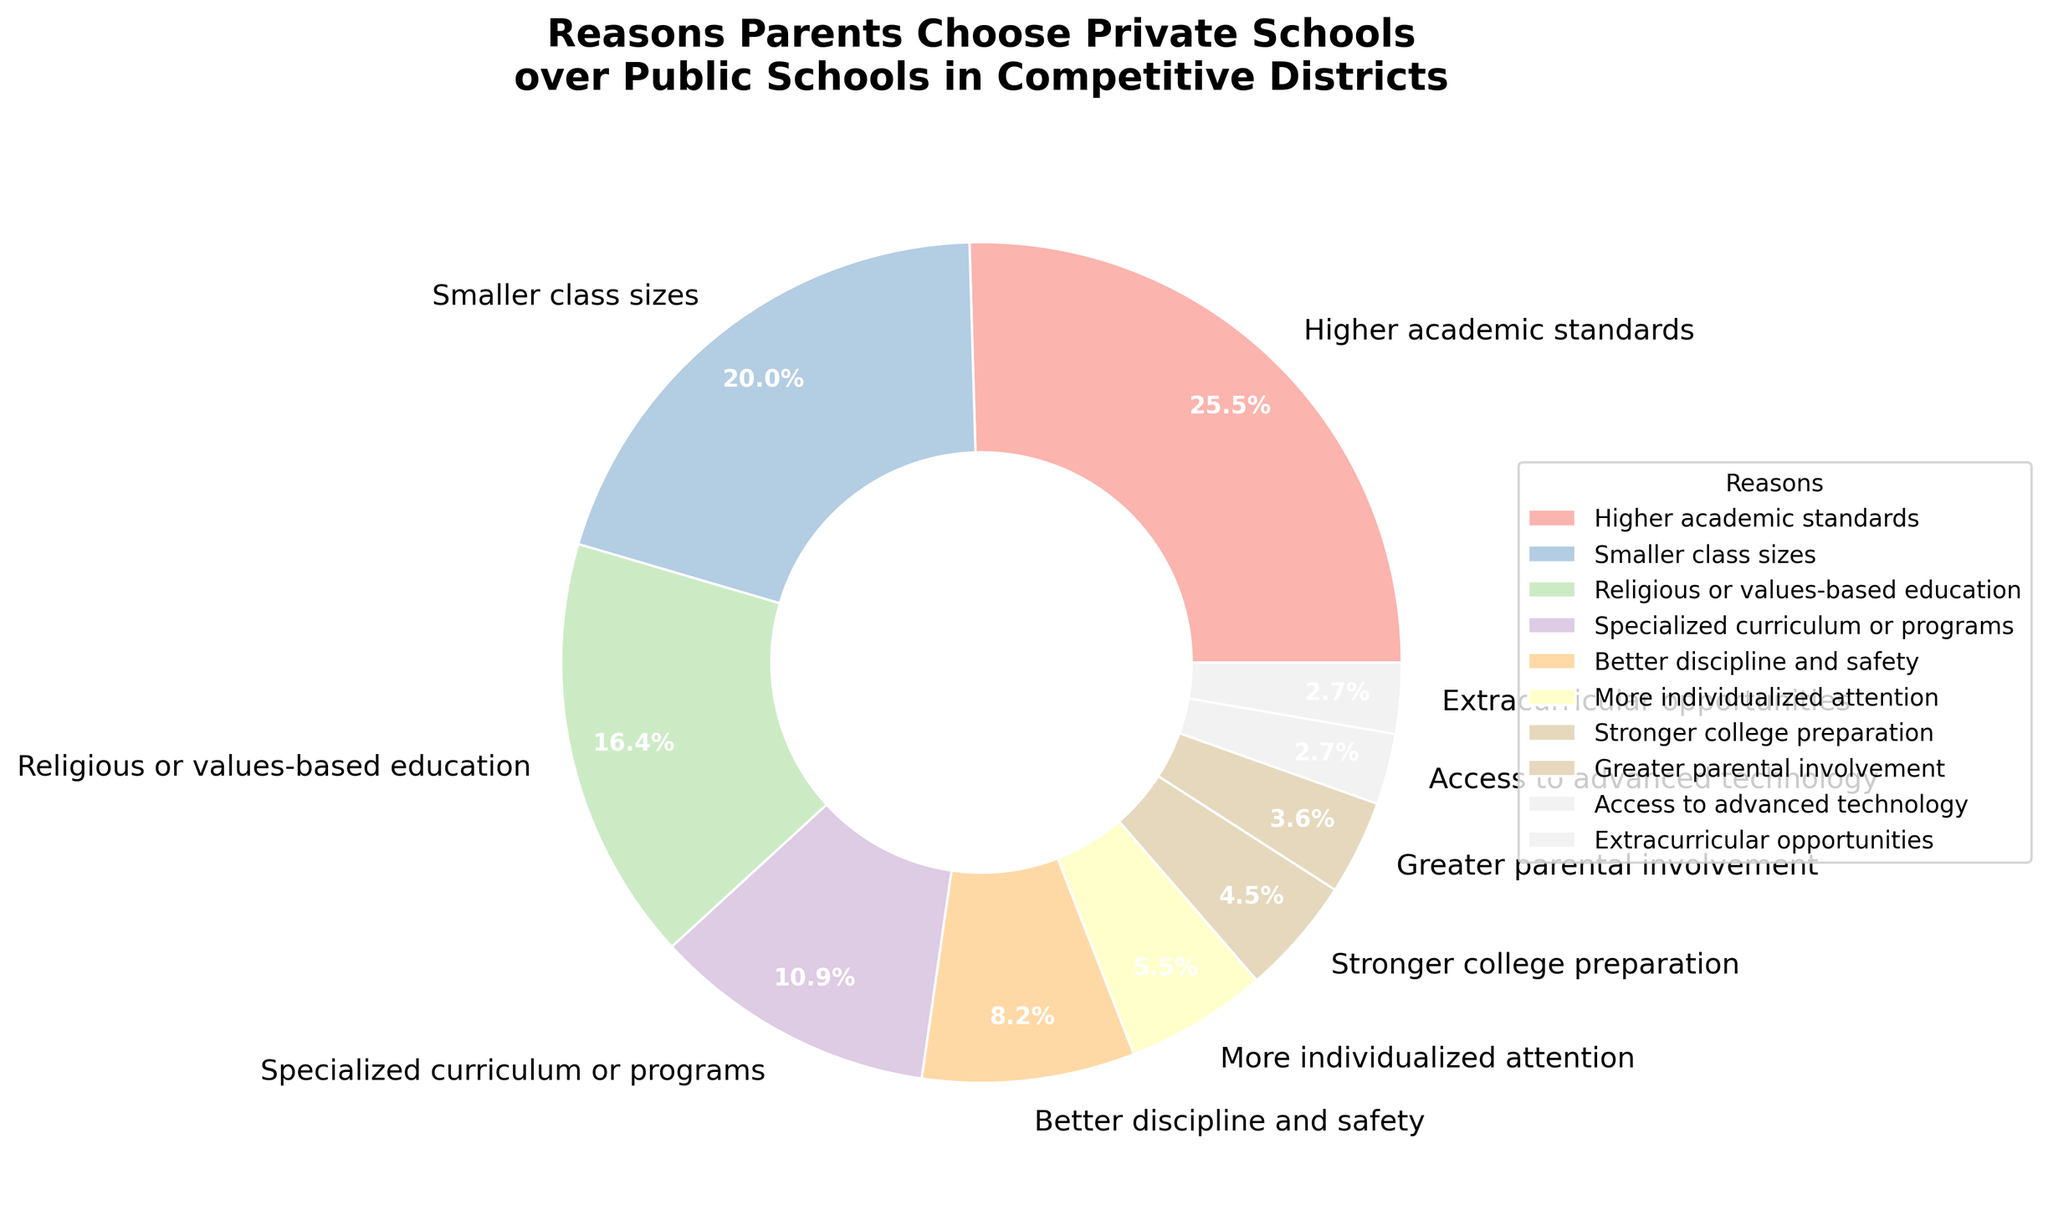what is the largest percentage segment in the pie chart? First, look at the segments of the pie chart and their corresponding labels. Identify which segment has the highest percentage value. According to the provided data, the reason "Higher academic standards" has the highest percentage at 28%.
Answer: Higher academic standards what is the combined percentage of "Smaller class sizes" and "Specialized curriculum or programs"? Locate the segments labeled "Smaller class sizes" and "Specialized curriculum or programs" in the chart. Add their percentages: 22% + 12% = 34%.
Answer: 34% Between "More individualized attention" and "Stronger college preparation," which reason has a higher percentage, and by how much? Identify the percentages for "More individualized attention" (6%) and "Stronger college preparation" (5%). Calculate the difference between the two: 6% - 5% = 1%.
Answer: More individualized attention, by 1% How much larger is the percentage for "Higher academic standards" compared to "Religious or values-based education"? First, note the percentages for "Higher academic standards" (28%) and "Religious or values-based education" (18%). Calculate the difference: 28% - 18% = 10%.
Answer: 10% What is the total percentage for all reasons related to academics (Higher academic standards, Specialized curriculum or programs, Stronger college preparation)? Sum the percentages of "Higher academic standards" (28%), "Specialized curriculum or programs" (12%), and "Stronger college preparation" (5%): 28% + 12% + 5% = 45%.
Answer: 45% Which reason has the smallest percentage, and what is that percentage? Identify the segment with the smallest percentage from the pie chart. According to the data, "Access to advanced technology" and "Extracurricular opportunities" both have the smallest percentage at 3%.
Answer: Access to advanced technology and Extracurricular opportunities, 3% What percentage of parents chose private schools for "Better discipline and safety" and "Greater parental involvement" combined? Find the percentages for "Better discipline and safety" (9%) and "Greater parental involvement" (4%). Add them together: 9% + 4% = 13%.
Answer: 13% Compare the combined percentage of "Higher academic standards" and "Religious or values-based education" to the total percentage for all other reasons. Which is higher? Calculate the combined percentage for "Higher academic standards" and "Religious or values-based education": 28% + 18% = 46%. Then, sum all other percentages: 100% - 46% = 54%. Thus, all other reasons combined have a higher percentage.
Answer: All other reasons, 54% Are the percentages for "More individualized attention" and "Greater parental involvement" together more or less than "Smaller class sizes"? Find the sum of "More individualized attention" (6%) and "Greater parental involvement" (4%): 6% + 4% = 10%. Compare this with "Smaller class sizes" (22%). Since 10% < 22%, it is less.
Answer: Less If a district were to only cater to reasons with percentages above 10%, which reasons would this include? List all reasons with percentages greater than 10%: "Higher academic standards" (28%), "Smaller class sizes" (22%), "Religious or values-based education" (18%), and "Specialized curriculum or programs" (12%).
Answer: Higher academic standards, Smaller class sizes, Religious or values-based education, Specialized curriculum or programs 